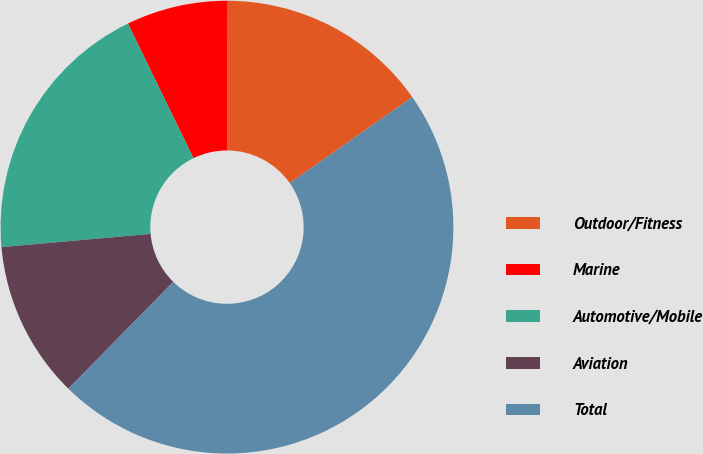Convert chart. <chart><loc_0><loc_0><loc_500><loc_500><pie_chart><fcel>Outdoor/Fitness<fcel>Marine<fcel>Automotive/Mobile<fcel>Aviation<fcel>Total<nl><fcel>15.22%<fcel>7.25%<fcel>19.2%<fcel>11.24%<fcel>47.09%<nl></chart> 